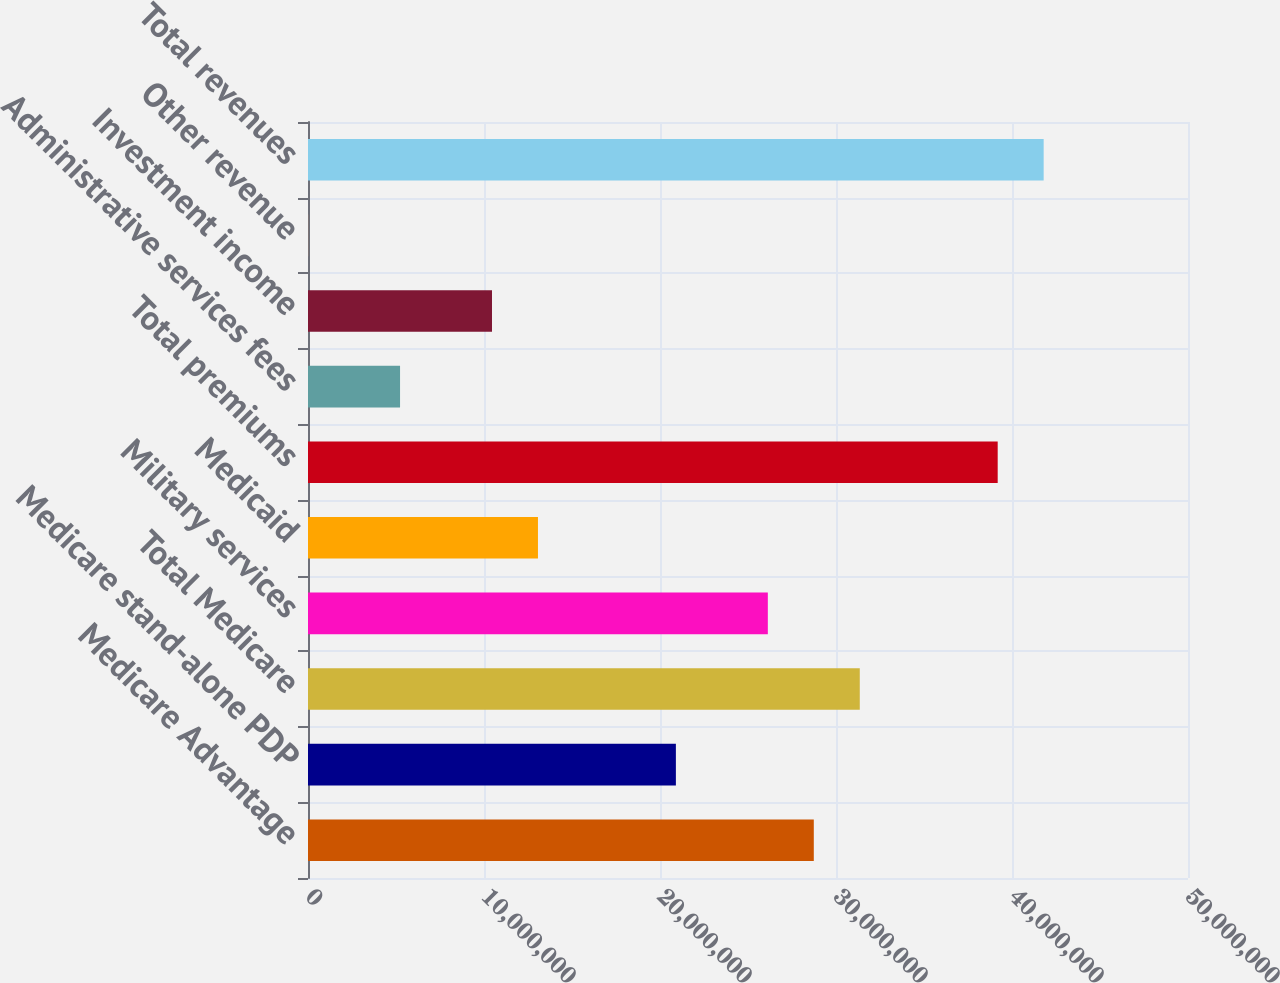Convert chart to OTSL. <chart><loc_0><loc_0><loc_500><loc_500><bar_chart><fcel>Medicare Advantage<fcel>Medicare stand-alone PDP<fcel>Total Medicare<fcel>Military services<fcel>Medicaid<fcel>Total premiums<fcel>Administrative services fees<fcel>Investment income<fcel>Other revenue<fcel>Total revenues<nl><fcel>2.87388e+07<fcel>2.09026e+07<fcel>3.13509e+07<fcel>2.61267e+07<fcel>1.30663e+07<fcel>3.91871e+07<fcel>5.2301e+06<fcel>1.04543e+07<fcel>5946<fcel>4.17992e+07<nl></chart> 